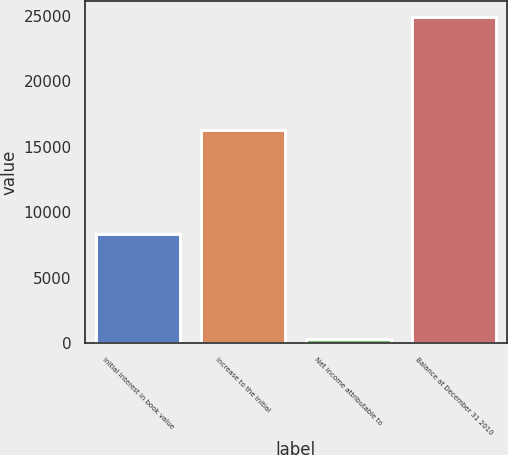Convert chart to OTSL. <chart><loc_0><loc_0><loc_500><loc_500><bar_chart><fcel>Initial interest in book value<fcel>Increase to the initial<fcel>Net income attributable to<fcel>Balance at December 31 2010<nl><fcel>8342<fcel>16285<fcel>276<fcel>24903<nl></chart> 